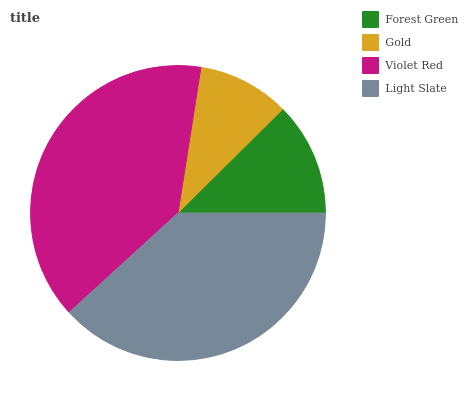Is Gold the minimum?
Answer yes or no. Yes. Is Violet Red the maximum?
Answer yes or no. Yes. Is Violet Red the minimum?
Answer yes or no. No. Is Gold the maximum?
Answer yes or no. No. Is Violet Red greater than Gold?
Answer yes or no. Yes. Is Gold less than Violet Red?
Answer yes or no. Yes. Is Gold greater than Violet Red?
Answer yes or no. No. Is Violet Red less than Gold?
Answer yes or no. No. Is Light Slate the high median?
Answer yes or no. Yes. Is Forest Green the low median?
Answer yes or no. Yes. Is Gold the high median?
Answer yes or no. No. Is Violet Red the low median?
Answer yes or no. No. 